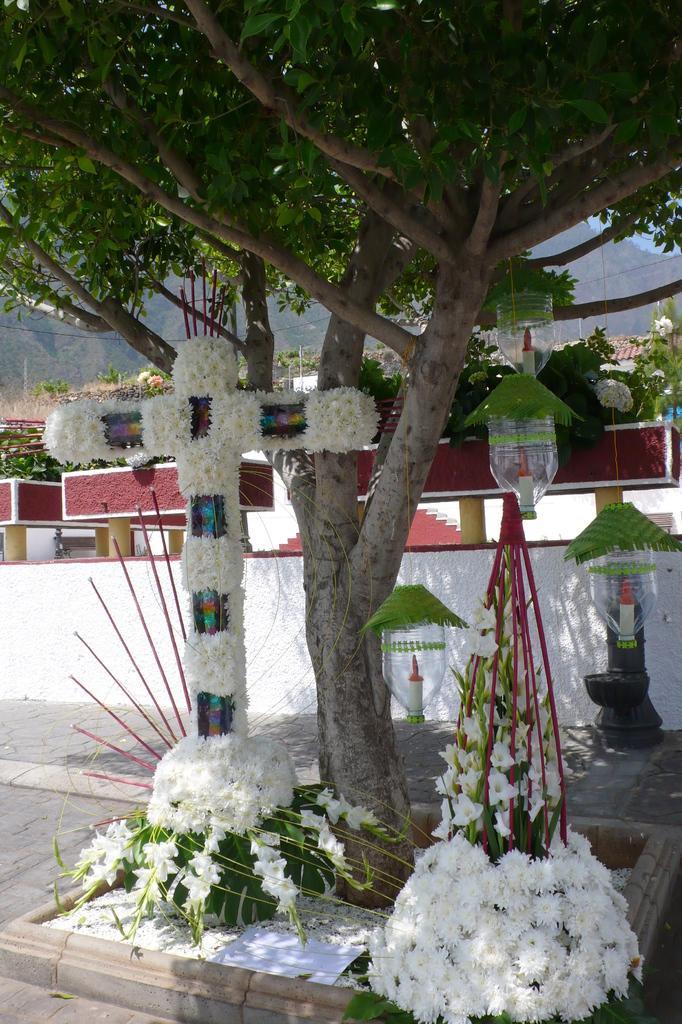Please provide a concise description of this image. In the given image i can see a tree,flowers,leaves,hanging bottles,building and in the background i can see the mountains. 